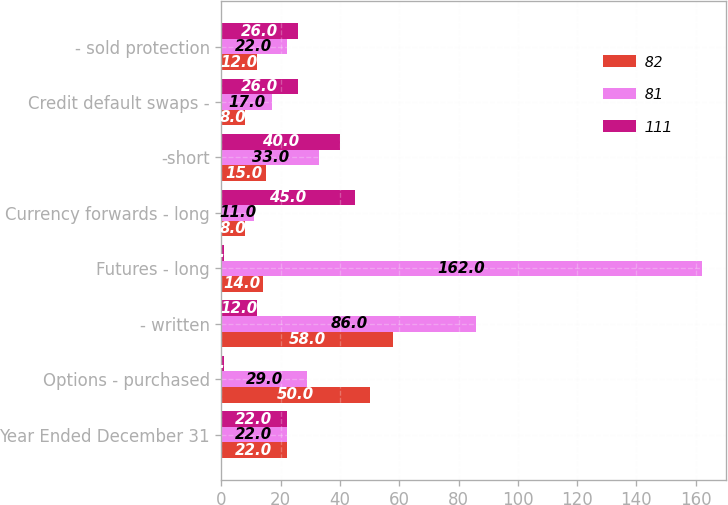Convert chart. <chart><loc_0><loc_0><loc_500><loc_500><stacked_bar_chart><ecel><fcel>Year Ended December 31<fcel>Options - purchased<fcel>- written<fcel>Futures - long<fcel>Currency forwards - long<fcel>-short<fcel>Credit default swaps -<fcel>- sold protection<nl><fcel>82<fcel>22<fcel>50<fcel>58<fcel>14<fcel>8<fcel>15<fcel>8<fcel>12<nl><fcel>81<fcel>22<fcel>29<fcel>86<fcel>162<fcel>11<fcel>33<fcel>17<fcel>22<nl><fcel>111<fcel>22<fcel>1<fcel>12<fcel>1<fcel>45<fcel>40<fcel>26<fcel>26<nl></chart> 